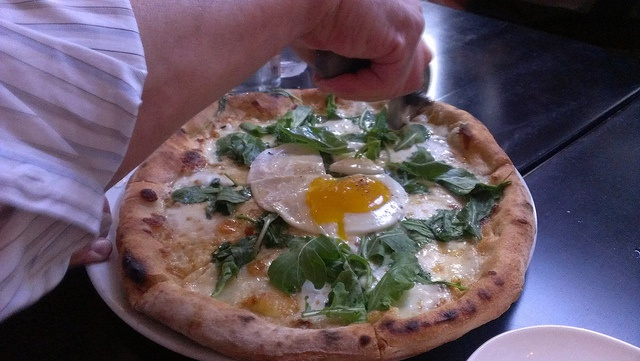Describe the objects in this image and their specific colors. I can see pizza in darkgray, gray, and black tones, people in darkgray, purple, maroon, violet, and gray tones, bowl in darkgray and lavender tones, knife in black and darkgray tones, and knife in darkgray, black, and gray tones in this image. 